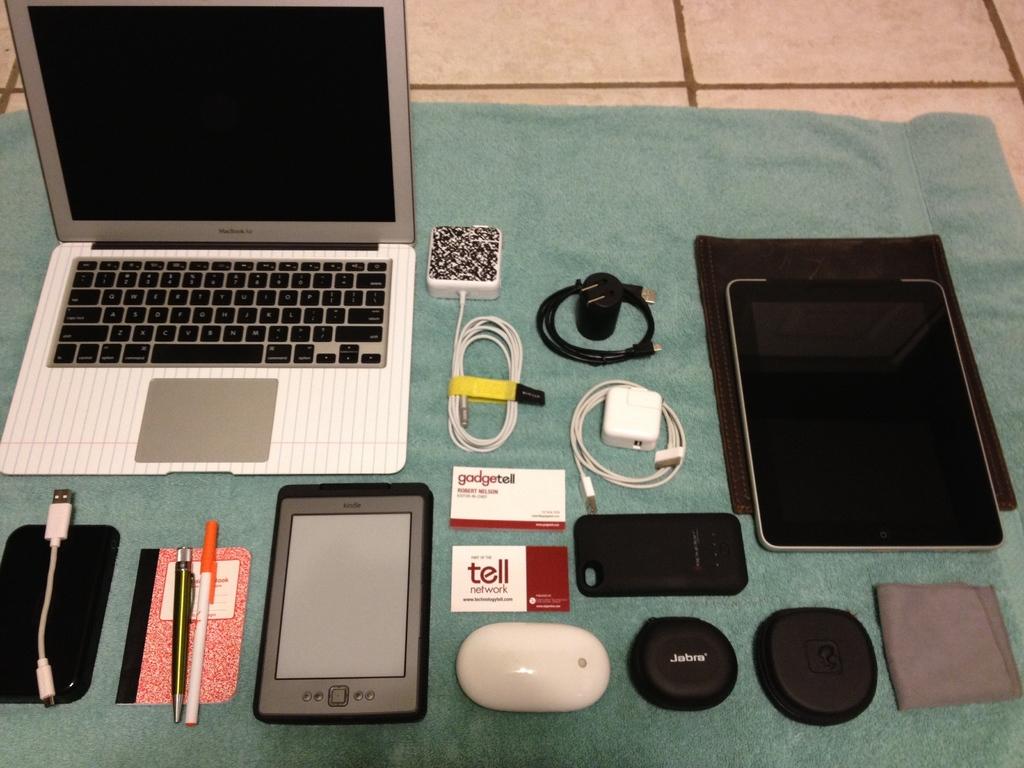What company is on the bottom business card?
Ensure brevity in your answer.  Tell. Do these business cards say gadgetell on them?
Your answer should be very brief. Yes. 